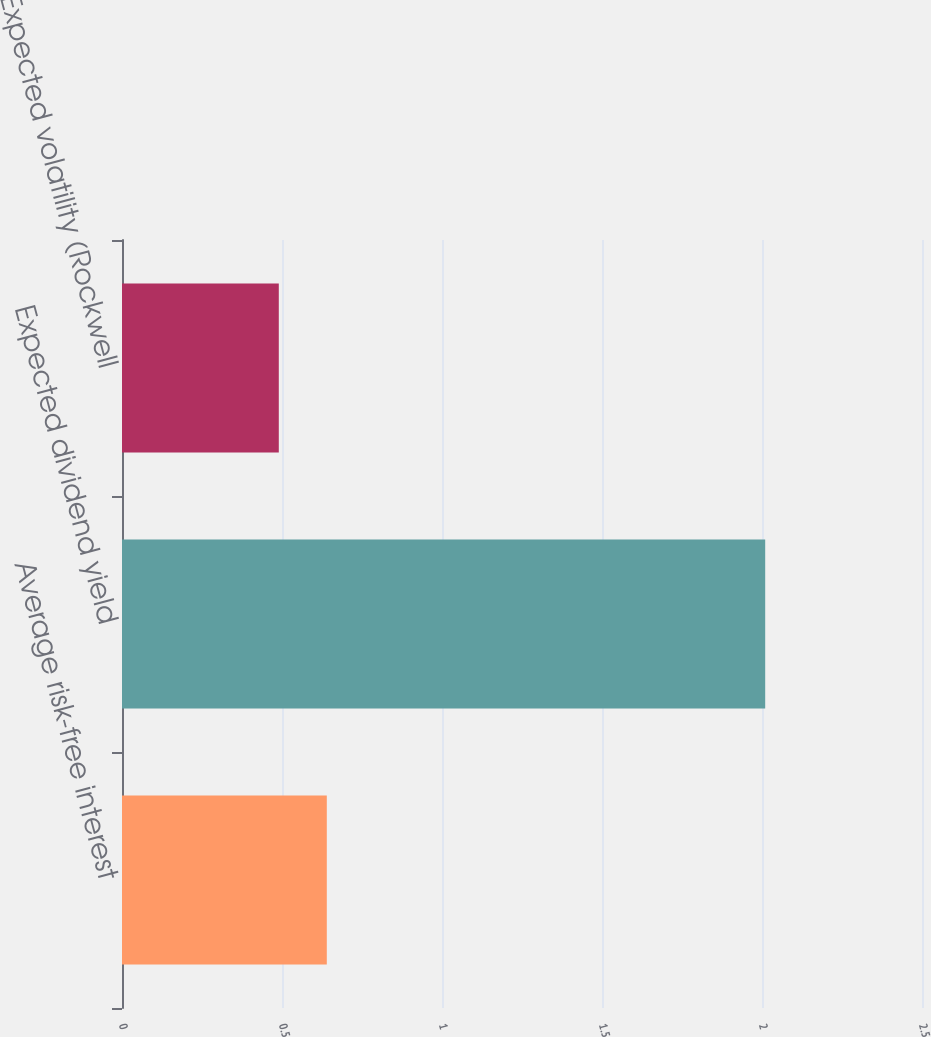Convert chart to OTSL. <chart><loc_0><loc_0><loc_500><loc_500><bar_chart><fcel>Average risk-free interest<fcel>Expected dividend yield<fcel>Expected volatility (Rockwell<nl><fcel>0.64<fcel>2.01<fcel>0.49<nl></chart> 